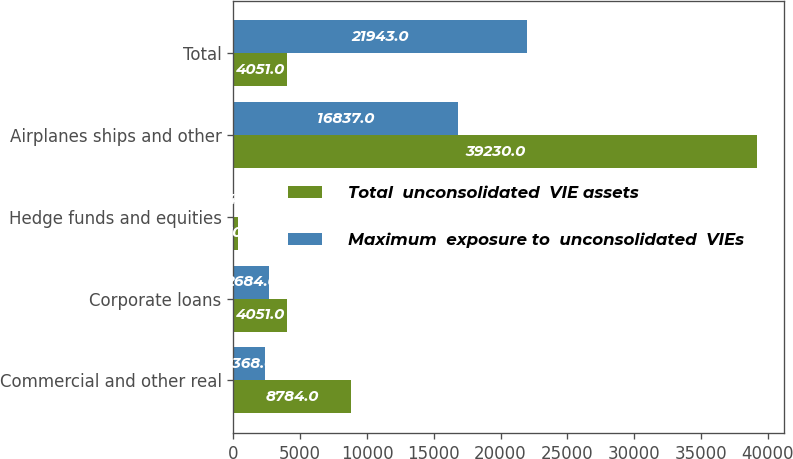<chart> <loc_0><loc_0><loc_500><loc_500><stacked_bar_chart><ecel><fcel>Commercial and other real<fcel>Corporate loans<fcel>Hedge funds and equities<fcel>Airplanes ships and other<fcel>Total<nl><fcel>Total  unconsolidated  VIE assets<fcel>8784<fcel>4051<fcel>370<fcel>39230<fcel>4051<nl><fcel>Maximum  exposure to  unconsolidated  VIEs<fcel>2368<fcel>2684<fcel>54<fcel>16837<fcel>21943<nl></chart> 